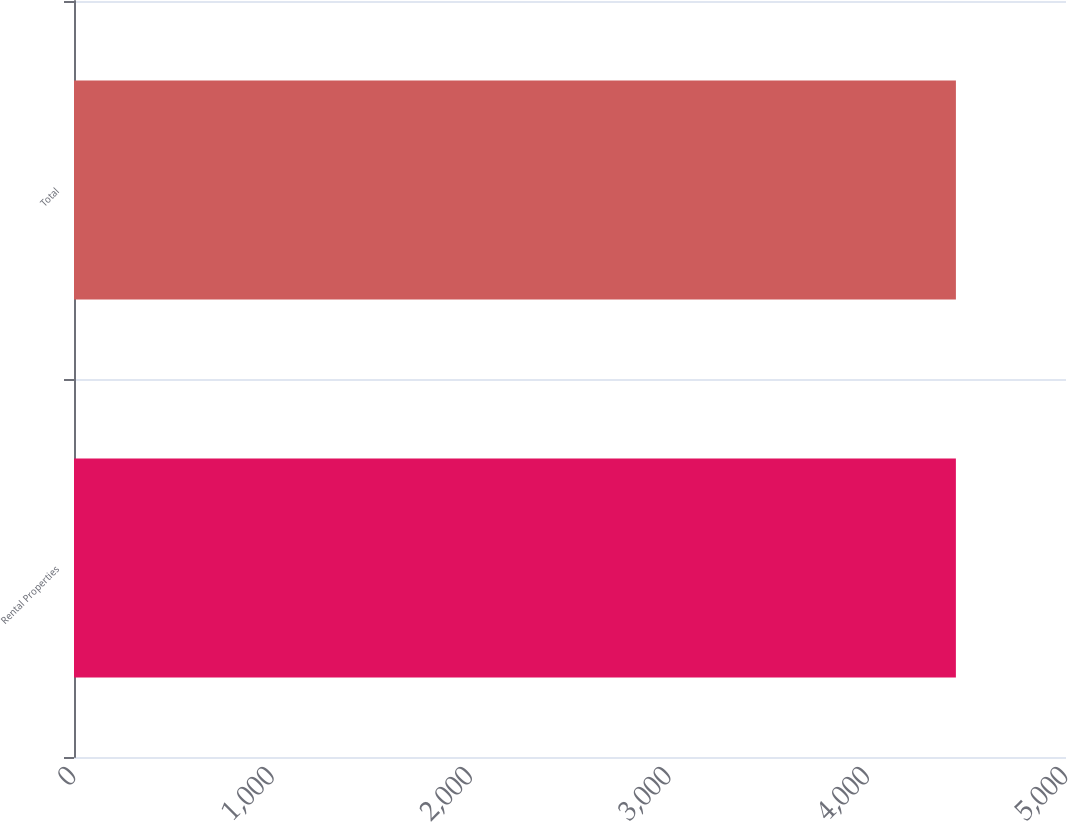Convert chart to OTSL. <chart><loc_0><loc_0><loc_500><loc_500><bar_chart><fcel>Rental Properties<fcel>Total<nl><fcel>4445<fcel>4445.1<nl></chart> 